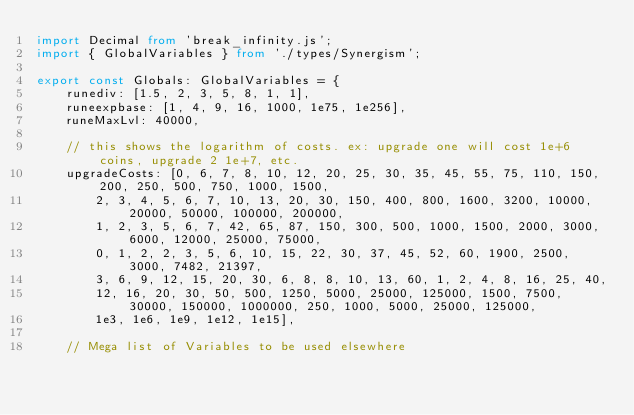<code> <loc_0><loc_0><loc_500><loc_500><_TypeScript_>import Decimal from 'break_infinity.js';
import { GlobalVariables } from './types/Synergism';

export const Globals: GlobalVariables = {
    runediv: [1.5, 2, 3, 5, 8, 1, 1],
    runeexpbase: [1, 4, 9, 16, 1000, 1e75, 1e256],
    runeMaxLvl: 40000,

    // this shows the logarithm of costs. ex: upgrade one will cost 1e+6 coins, upgrade 2 1e+7, etc.
    upgradeCosts: [0, 6, 7, 8, 10, 12, 20, 25, 30, 35, 45, 55, 75, 110, 150, 200, 250, 500, 750, 1000, 1500,
        2, 3, 4, 5, 6, 7, 10, 13, 20, 30, 150, 400, 800, 1600, 3200, 10000, 20000, 50000, 100000, 200000,
        1, 2, 3, 5, 6, 7, 42, 65, 87, 150, 300, 500, 1000, 1500, 2000, 3000, 6000, 12000, 25000, 75000,
        0, 1, 2, 2, 3, 5, 6, 10, 15, 22, 30, 37, 45, 52, 60, 1900, 2500, 3000, 7482, 21397,
        3, 6, 9, 12, 15, 20, 30, 6, 8, 8, 10, 13, 60, 1, 2, 4, 8, 16, 25, 40,
        12, 16, 20, 30, 50, 500, 1250, 5000, 25000, 125000, 1500, 7500, 30000, 150000, 1000000, 250, 1000, 5000, 25000, 125000,
        1e3, 1e6, 1e9, 1e12, 1e15],

    // Mega list of Variables to be used elsewhere</code> 